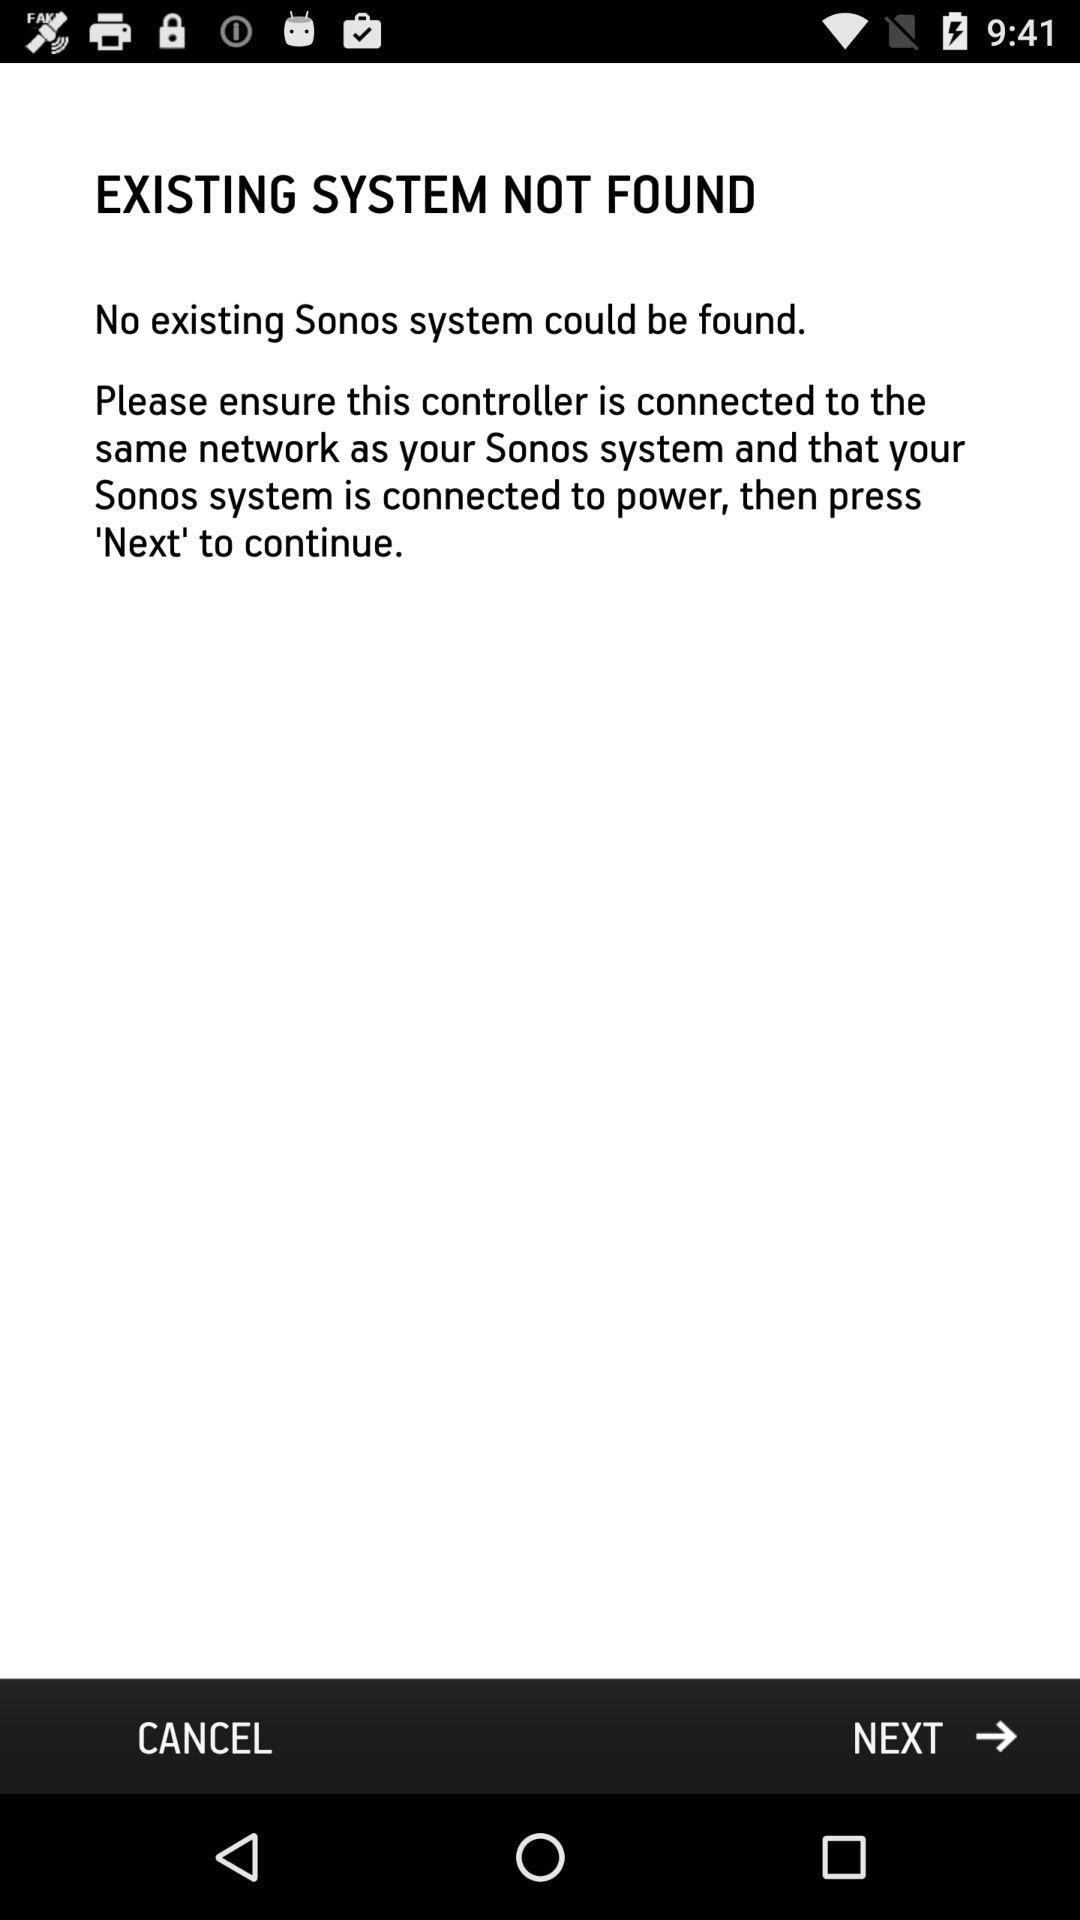Are there any existing "Sonos system" found? There is no Sonos system. 